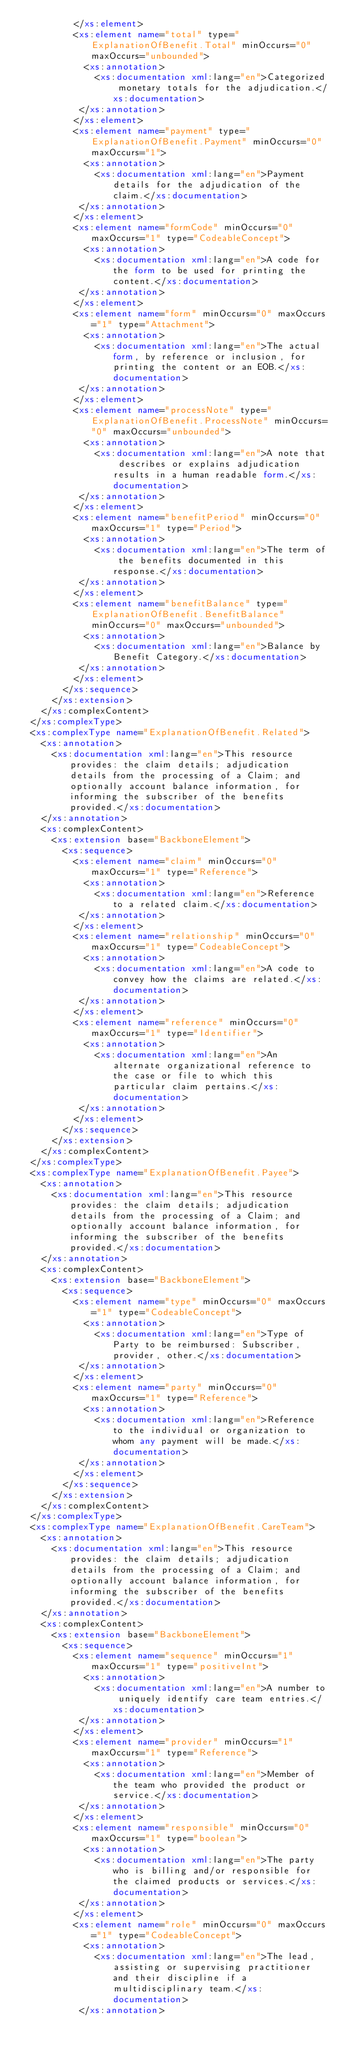Convert code to text. <code><loc_0><loc_0><loc_500><loc_500><_XML_>          </xs:element>
          <xs:element name="total" type="ExplanationOfBenefit.Total" minOccurs="0" maxOccurs="unbounded">
            <xs:annotation>
              <xs:documentation xml:lang="en">Categorized monetary totals for the adjudication.</xs:documentation>
           </xs:annotation>
          </xs:element>
          <xs:element name="payment" type="ExplanationOfBenefit.Payment" minOccurs="0" maxOccurs="1">
            <xs:annotation>
              <xs:documentation xml:lang="en">Payment details for the adjudication of the claim.</xs:documentation>
           </xs:annotation>
          </xs:element>
          <xs:element name="formCode" minOccurs="0" maxOccurs="1" type="CodeableConcept">
            <xs:annotation>
              <xs:documentation xml:lang="en">A code for the form to be used for printing the content.</xs:documentation>
           </xs:annotation>
          </xs:element>
          <xs:element name="form" minOccurs="0" maxOccurs="1" type="Attachment">
            <xs:annotation>
              <xs:documentation xml:lang="en">The actual form, by reference or inclusion, for printing the content or an EOB.</xs:documentation>
           </xs:annotation>
          </xs:element>
          <xs:element name="processNote" type="ExplanationOfBenefit.ProcessNote" minOccurs="0" maxOccurs="unbounded">
            <xs:annotation>
              <xs:documentation xml:lang="en">A note that describes or explains adjudication results in a human readable form.</xs:documentation>
           </xs:annotation>
          </xs:element>
          <xs:element name="benefitPeriod" minOccurs="0" maxOccurs="1" type="Period">
            <xs:annotation>
              <xs:documentation xml:lang="en">The term of the benefits documented in this response.</xs:documentation>
           </xs:annotation>
          </xs:element>
          <xs:element name="benefitBalance" type="ExplanationOfBenefit.BenefitBalance" minOccurs="0" maxOccurs="unbounded">
            <xs:annotation>
              <xs:documentation xml:lang="en">Balance by Benefit Category.</xs:documentation>
           </xs:annotation>
          </xs:element>
        </xs:sequence>
      </xs:extension>
    </xs:complexContent>
  </xs:complexType>
  <xs:complexType name="ExplanationOfBenefit.Related">
    <xs:annotation>
      <xs:documentation xml:lang="en">This resource provides: the claim details; adjudication details from the processing of a Claim; and optionally account balance information, for informing the subscriber of the benefits provided.</xs:documentation>
    </xs:annotation>
    <xs:complexContent>
      <xs:extension base="BackboneElement">
        <xs:sequence>
          <xs:element name="claim" minOccurs="0" maxOccurs="1" type="Reference">
            <xs:annotation>
              <xs:documentation xml:lang="en">Reference to a related claim.</xs:documentation>
           </xs:annotation>
          </xs:element>
          <xs:element name="relationship" minOccurs="0" maxOccurs="1" type="CodeableConcept">
            <xs:annotation>
              <xs:documentation xml:lang="en">A code to convey how the claims are related.</xs:documentation>
           </xs:annotation>
          </xs:element>
          <xs:element name="reference" minOccurs="0" maxOccurs="1" type="Identifier">
            <xs:annotation>
              <xs:documentation xml:lang="en">An alternate organizational reference to the case or file to which this particular claim pertains.</xs:documentation>
           </xs:annotation>
          </xs:element>
        </xs:sequence>
      </xs:extension>
    </xs:complexContent>
  </xs:complexType>
  <xs:complexType name="ExplanationOfBenefit.Payee">
    <xs:annotation>
      <xs:documentation xml:lang="en">This resource provides: the claim details; adjudication details from the processing of a Claim; and optionally account balance information, for informing the subscriber of the benefits provided.</xs:documentation>
    </xs:annotation>
    <xs:complexContent>
      <xs:extension base="BackboneElement">
        <xs:sequence>
          <xs:element name="type" minOccurs="0" maxOccurs="1" type="CodeableConcept">
            <xs:annotation>
              <xs:documentation xml:lang="en">Type of Party to be reimbursed: Subscriber, provider, other.</xs:documentation>
           </xs:annotation>
          </xs:element>
          <xs:element name="party" minOccurs="0" maxOccurs="1" type="Reference">
            <xs:annotation>
              <xs:documentation xml:lang="en">Reference to the individual or organization to whom any payment will be made.</xs:documentation>
           </xs:annotation>
          </xs:element>
        </xs:sequence>
      </xs:extension>
    </xs:complexContent>
  </xs:complexType>
  <xs:complexType name="ExplanationOfBenefit.CareTeam">
    <xs:annotation>
      <xs:documentation xml:lang="en">This resource provides: the claim details; adjudication details from the processing of a Claim; and optionally account balance information, for informing the subscriber of the benefits provided.</xs:documentation>
    </xs:annotation>
    <xs:complexContent>
      <xs:extension base="BackboneElement">
        <xs:sequence>
          <xs:element name="sequence" minOccurs="1" maxOccurs="1" type="positiveInt">
            <xs:annotation>
              <xs:documentation xml:lang="en">A number to uniquely identify care team entries.</xs:documentation>
           </xs:annotation>
          </xs:element>
          <xs:element name="provider" minOccurs="1" maxOccurs="1" type="Reference">
            <xs:annotation>
              <xs:documentation xml:lang="en">Member of the team who provided the product or service.</xs:documentation>
           </xs:annotation>
          </xs:element>
          <xs:element name="responsible" minOccurs="0" maxOccurs="1" type="boolean">
            <xs:annotation>
              <xs:documentation xml:lang="en">The party who is billing and/or responsible for the claimed products or services.</xs:documentation>
           </xs:annotation>
          </xs:element>
          <xs:element name="role" minOccurs="0" maxOccurs="1" type="CodeableConcept">
            <xs:annotation>
              <xs:documentation xml:lang="en">The lead, assisting or supervising practitioner and their discipline if a multidisciplinary team.</xs:documentation>
           </xs:annotation></code> 